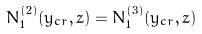Convert formula to latex. <formula><loc_0><loc_0><loc_500><loc_500>N _ { 1 } ^ { ( 2 ) } ( y _ { c r } , z ) = N _ { 1 } ^ { ( 3 ) } ( y _ { c r } , z )</formula> 